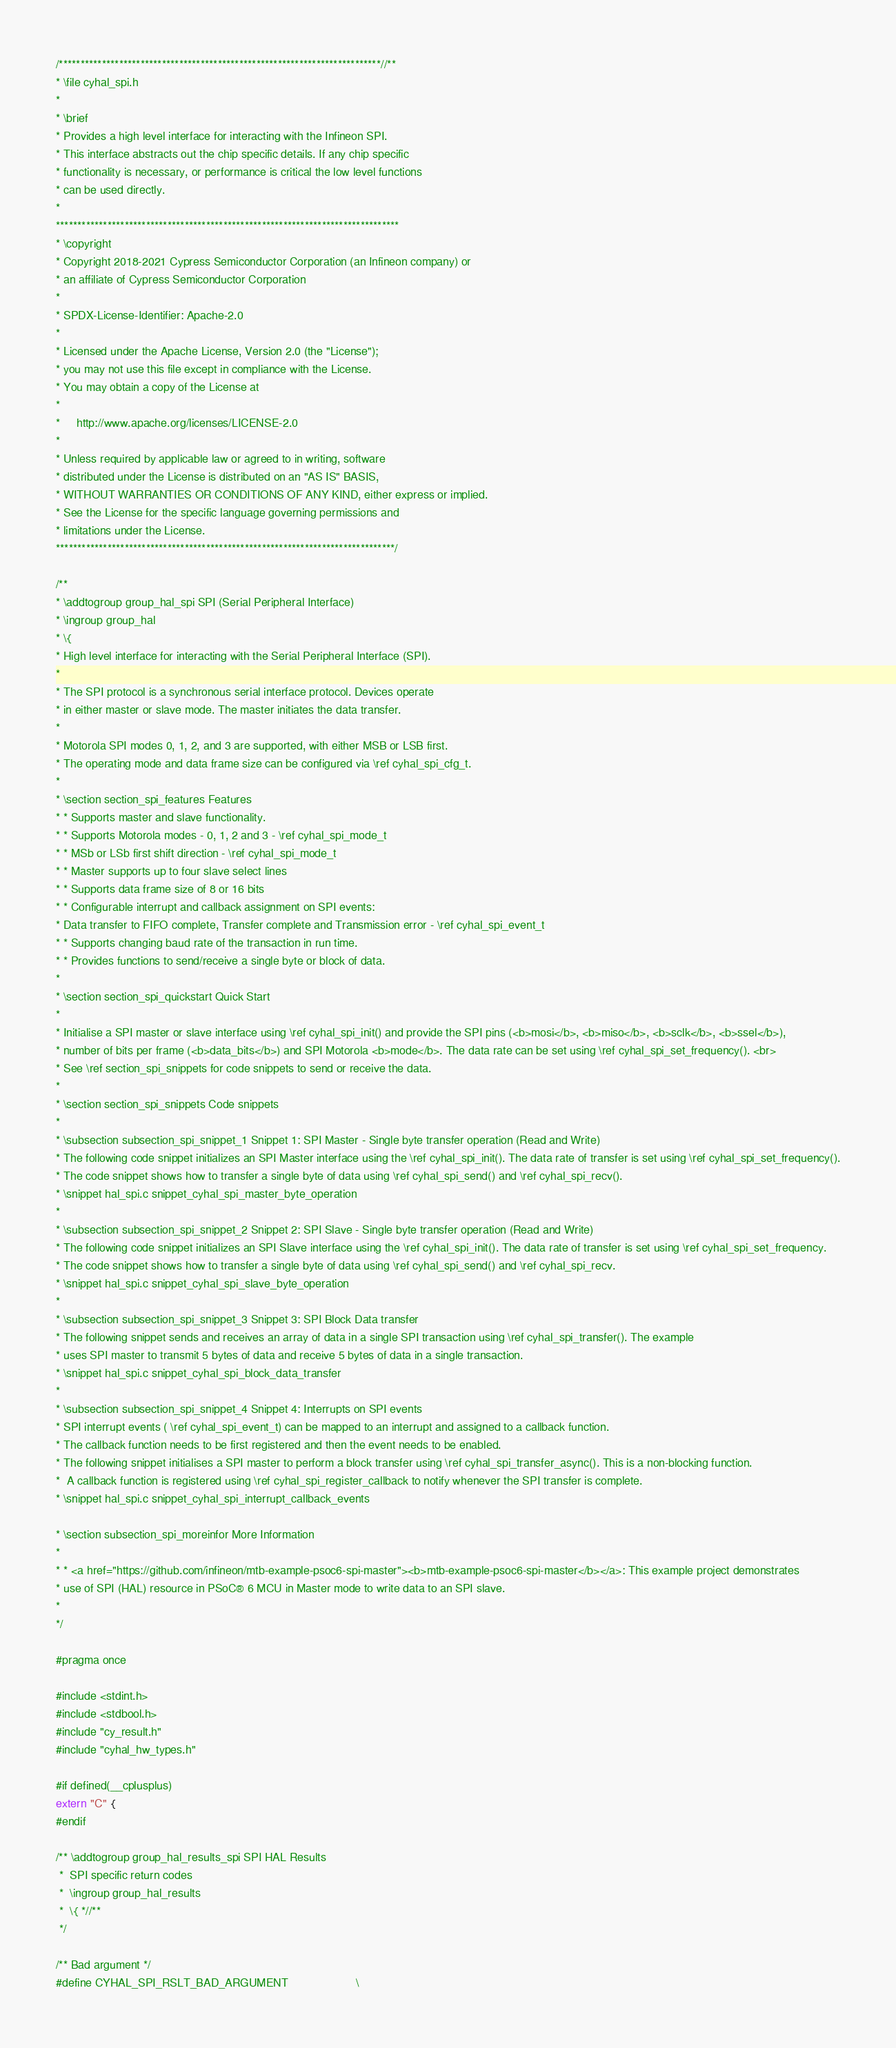<code> <loc_0><loc_0><loc_500><loc_500><_C_>/***************************************************************************//**
* \file cyhal_spi.h
*
* \brief
* Provides a high level interface for interacting with the Infineon SPI.
* This interface abstracts out the chip specific details. If any chip specific
* functionality is necessary, or performance is critical the low level functions
* can be used directly.
*
********************************************************************************
* \copyright
* Copyright 2018-2021 Cypress Semiconductor Corporation (an Infineon company) or
* an affiliate of Cypress Semiconductor Corporation
*
* SPDX-License-Identifier: Apache-2.0
*
* Licensed under the Apache License, Version 2.0 (the "License");
* you may not use this file except in compliance with the License.
* You may obtain a copy of the License at
*
*     http://www.apache.org/licenses/LICENSE-2.0
*
* Unless required by applicable law or agreed to in writing, software
* distributed under the License is distributed on an "AS IS" BASIS,
* WITHOUT WARRANTIES OR CONDITIONS OF ANY KIND, either express or implied.
* See the License for the specific language governing permissions and
* limitations under the License.
*******************************************************************************/

/**
* \addtogroup group_hal_spi SPI (Serial Peripheral Interface)
* \ingroup group_hal
* \{
* High level interface for interacting with the Serial Peripheral Interface (SPI).
*
* The SPI protocol is a synchronous serial interface protocol. Devices operate
* in either master or slave mode. The master initiates the data transfer.
*
* Motorola SPI modes 0, 1, 2, and 3 are supported, with either MSB or LSB first.
* The operating mode and data frame size can be configured via \ref cyhal_spi_cfg_t.
*
* \section section_spi_features Features
* * Supports master and slave functionality.
* * Supports Motorola modes - 0, 1, 2 and 3 - \ref cyhal_spi_mode_t
* * MSb or LSb first shift direction - \ref cyhal_spi_mode_t
* * Master supports up to four slave select lines
* * Supports data frame size of 8 or 16 bits
* * Configurable interrupt and callback assignment on SPI events:
* Data transfer to FIFO complete, Transfer complete and Transmission error - \ref cyhal_spi_event_t
* * Supports changing baud rate of the transaction in run time.
* * Provides functions to send/receive a single byte or block of data.
*
* \section section_spi_quickstart Quick Start
*
* Initialise a SPI master or slave interface using \ref cyhal_spi_init() and provide the SPI pins (<b>mosi</b>, <b>miso</b>, <b>sclk</b>, <b>ssel</b>),
* number of bits per frame (<b>data_bits</b>) and SPI Motorola <b>mode</b>. The data rate can be set using \ref cyhal_spi_set_frequency(). <br>
* See \ref section_spi_snippets for code snippets to send or receive the data.
*
* \section section_spi_snippets Code snippets
*
* \subsection subsection_spi_snippet_1 Snippet 1: SPI Master - Single byte transfer operation (Read and Write)
* The following code snippet initializes an SPI Master interface using the \ref cyhal_spi_init(). The data rate of transfer is set using \ref cyhal_spi_set_frequency().
* The code snippet shows how to transfer a single byte of data using \ref cyhal_spi_send() and \ref cyhal_spi_recv().
* \snippet hal_spi.c snippet_cyhal_spi_master_byte_operation
*
* \subsection subsection_spi_snippet_2 Snippet 2: SPI Slave - Single byte transfer operation (Read and Write)
* The following code snippet initializes an SPI Slave interface using the \ref cyhal_spi_init(). The data rate of transfer is set using \ref cyhal_spi_set_frequency.
* The code snippet shows how to transfer a single byte of data using \ref cyhal_spi_send() and \ref cyhal_spi_recv.
* \snippet hal_spi.c snippet_cyhal_spi_slave_byte_operation
*
* \subsection subsection_spi_snippet_3 Snippet 3: SPI Block Data transfer
* The following snippet sends and receives an array of data in a single SPI transaction using \ref cyhal_spi_transfer(). The example
* uses SPI master to transmit 5 bytes of data and receive 5 bytes of data in a single transaction.
* \snippet hal_spi.c snippet_cyhal_spi_block_data_transfer
*
* \subsection subsection_spi_snippet_4 Snippet 4: Interrupts on SPI events
* SPI interrupt events ( \ref cyhal_spi_event_t) can be mapped to an interrupt and assigned to a callback function.
* The callback function needs to be first registered and then the event needs to be enabled.
* The following snippet initialises a SPI master to perform a block transfer using \ref cyhal_spi_transfer_async(). This is a non-blocking function.
*  A callback function is registered using \ref cyhal_spi_register_callback to notify whenever the SPI transfer is complete.
* \snippet hal_spi.c snippet_cyhal_spi_interrupt_callback_events

* \section subsection_spi_moreinfor More Information
*
* * <a href="https://github.com/infineon/mtb-example-psoc6-spi-master"><b>mtb-example-psoc6-spi-master</b></a>: This example project demonstrates
* use of SPI (HAL) resource in PSoC® 6 MCU in Master mode to write data to an SPI slave.
*
*/

#pragma once

#include <stdint.h>
#include <stdbool.h>
#include "cy_result.h"
#include "cyhal_hw_types.h"

#if defined(__cplusplus)
extern "C" {
#endif

/** \addtogroup group_hal_results_spi SPI HAL Results
 *  SPI specific return codes
 *  \ingroup group_hal_results
 *  \{ *//**
 */

/** Bad argument */
#define CYHAL_SPI_RSLT_BAD_ARGUMENT                     \</code> 